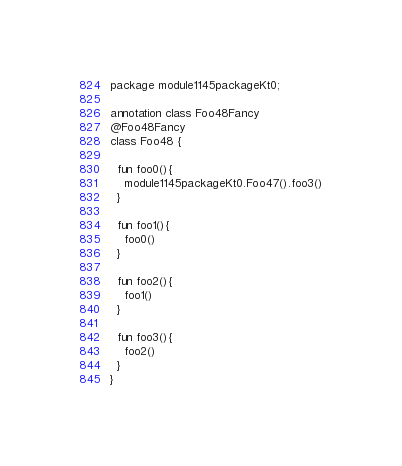Convert code to text. <code><loc_0><loc_0><loc_500><loc_500><_Kotlin_>package module1145packageKt0;

annotation class Foo48Fancy
@Foo48Fancy
class Foo48 {

  fun foo0(){
    module1145packageKt0.Foo47().foo3()
  }

  fun foo1(){
    foo0()
  }

  fun foo2(){
    foo1()
  }

  fun foo3(){
    foo2()
  }
}</code> 